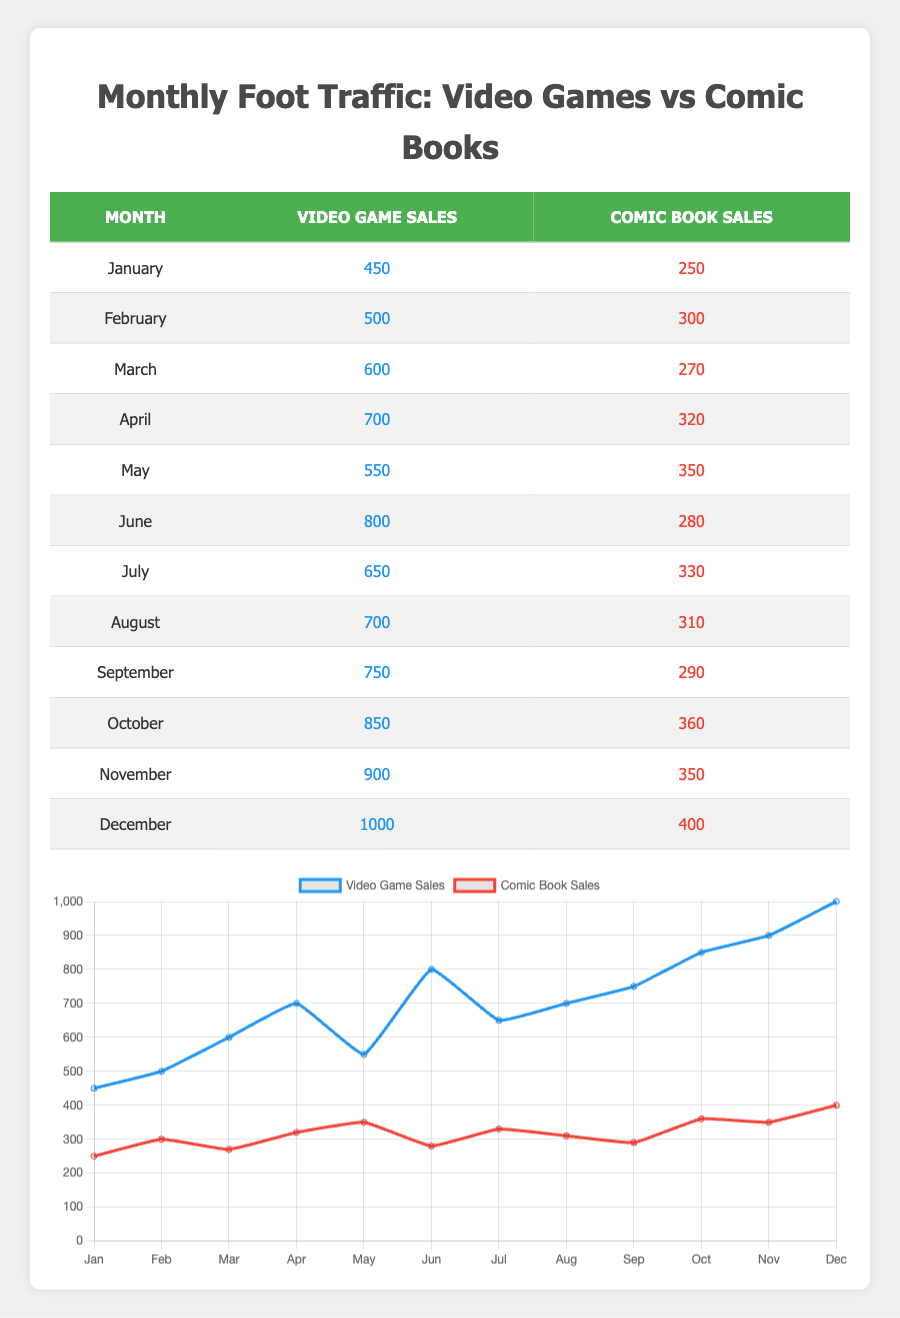What month had the highest video game sales in-store? The highest video game sales in-store can be found by reviewing the video game sales column for each month. December has 1000, which is greater than any other month.
Answer: December Which month had the least comic book sales and what was the value? To find the month with the least comic book sales, examine the comic book sales column. March shows the lowest sales with a value of 270.
Answer: March, 270 What is the total foot traffic for video game sales over the months of January to June? To find the total foot traffic for video game sales from January to June, sum the values from each month: 450 + 500 + 600 + 700 + 550 + 800 = 3600.
Answer: 3600 Did comic book sales ever exceed 400 during the year? From the table, the maximum comic book sales recorded is 400 in December; therefore, it did not exceed that value.
Answer: No What is the average monthly foot traffic for comic book sales? The average monthly foot traffic can be calculated by adding all the comic book sales and dividing by 12 months: (250 + 300 + 270 + 320 + 350 + 280 + 330 + 310 + 290 + 360 + 350 + 400) = 3960, and then divide by 12 to get the average 3960/12 = 330.
Answer: 330 How many months had video game sales over 700? By reviewing the video game sales data, the months with sales over 700 are April, June, July, August, September, October, November, and December. This totals 8 months.
Answer: 8 What was the difference in sales between video games and comic books in October? To find the difference in sales for October, subtract the comic book sales from the video game sales: 850 - 360 = 490.
Answer: 490 Which month showed the closest video game sales to comic book sales? Comparing the values month by month, May showed the closest with video game sales of 550 and comic book sales of 350, giving a difference of 200.
Answer: May 